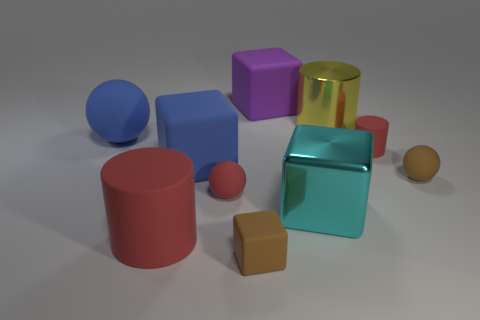Subtract all big purple blocks. How many blocks are left? 3 Subtract all brown cubes. How many red cylinders are left? 2 Subtract 4 blocks. How many blocks are left? 0 Subtract all cylinders. How many objects are left? 7 Subtract all yellow cylinders. How many cylinders are left? 2 Subtract 0 yellow cubes. How many objects are left? 10 Subtract all brown cylinders. Subtract all red blocks. How many cylinders are left? 3 Subtract all big red matte cylinders. Subtract all brown matte things. How many objects are left? 7 Add 9 small cylinders. How many small cylinders are left? 10 Add 4 big purple blocks. How many big purple blocks exist? 5 